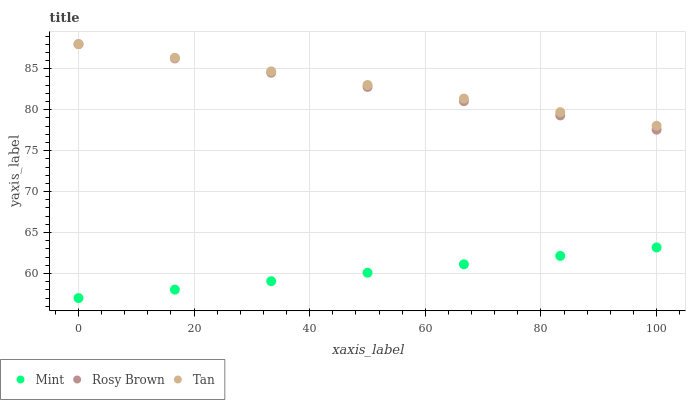Does Mint have the minimum area under the curve?
Answer yes or no. Yes. Does Tan have the maximum area under the curve?
Answer yes or no. Yes. Does Rosy Brown have the minimum area under the curve?
Answer yes or no. No. Does Rosy Brown have the maximum area under the curve?
Answer yes or no. No. Is Tan the smoothest?
Answer yes or no. Yes. Is Mint the roughest?
Answer yes or no. Yes. Is Rosy Brown the smoothest?
Answer yes or no. No. Is Rosy Brown the roughest?
Answer yes or no. No. Does Mint have the lowest value?
Answer yes or no. Yes. Does Rosy Brown have the lowest value?
Answer yes or no. No. Does Rosy Brown have the highest value?
Answer yes or no. Yes. Does Mint have the highest value?
Answer yes or no. No. Is Mint less than Tan?
Answer yes or no. Yes. Is Tan greater than Mint?
Answer yes or no. Yes. Does Rosy Brown intersect Tan?
Answer yes or no. Yes. Is Rosy Brown less than Tan?
Answer yes or no. No. Is Rosy Brown greater than Tan?
Answer yes or no. No. Does Mint intersect Tan?
Answer yes or no. No. 